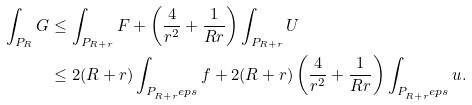<formula> <loc_0><loc_0><loc_500><loc_500>\int _ { P _ { R } } G & \leq \int _ { P _ { R + r } } F + \left ( \frac { 4 } { r ^ { 2 } } + \frac { 1 } { R r } \right ) \int _ { P _ { R + r } } U \\ & \leq 2 ( R + r ) \int _ { P _ { R + r } ^ { \ } e p s } f + 2 ( R + r ) \left ( \frac { 4 } { r ^ { 2 } } + \frac { 1 } { R r } \right ) \int _ { P _ { R + r } ^ { \ } e p s } u .</formula> 